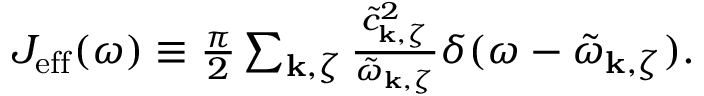Convert formula to latex. <formula><loc_0><loc_0><loc_500><loc_500>\begin{array} { r } { J _ { e f f } ( \omega ) \equiv \frac { \pi } { 2 } \sum _ { k , \zeta } \frac { \tilde { c } _ { k , \zeta } ^ { 2 } } { \tilde { \omega } _ { k , \zeta } } \delta ( \omega - \tilde { \omega } _ { k , \zeta } ) . } \end{array}</formula> 